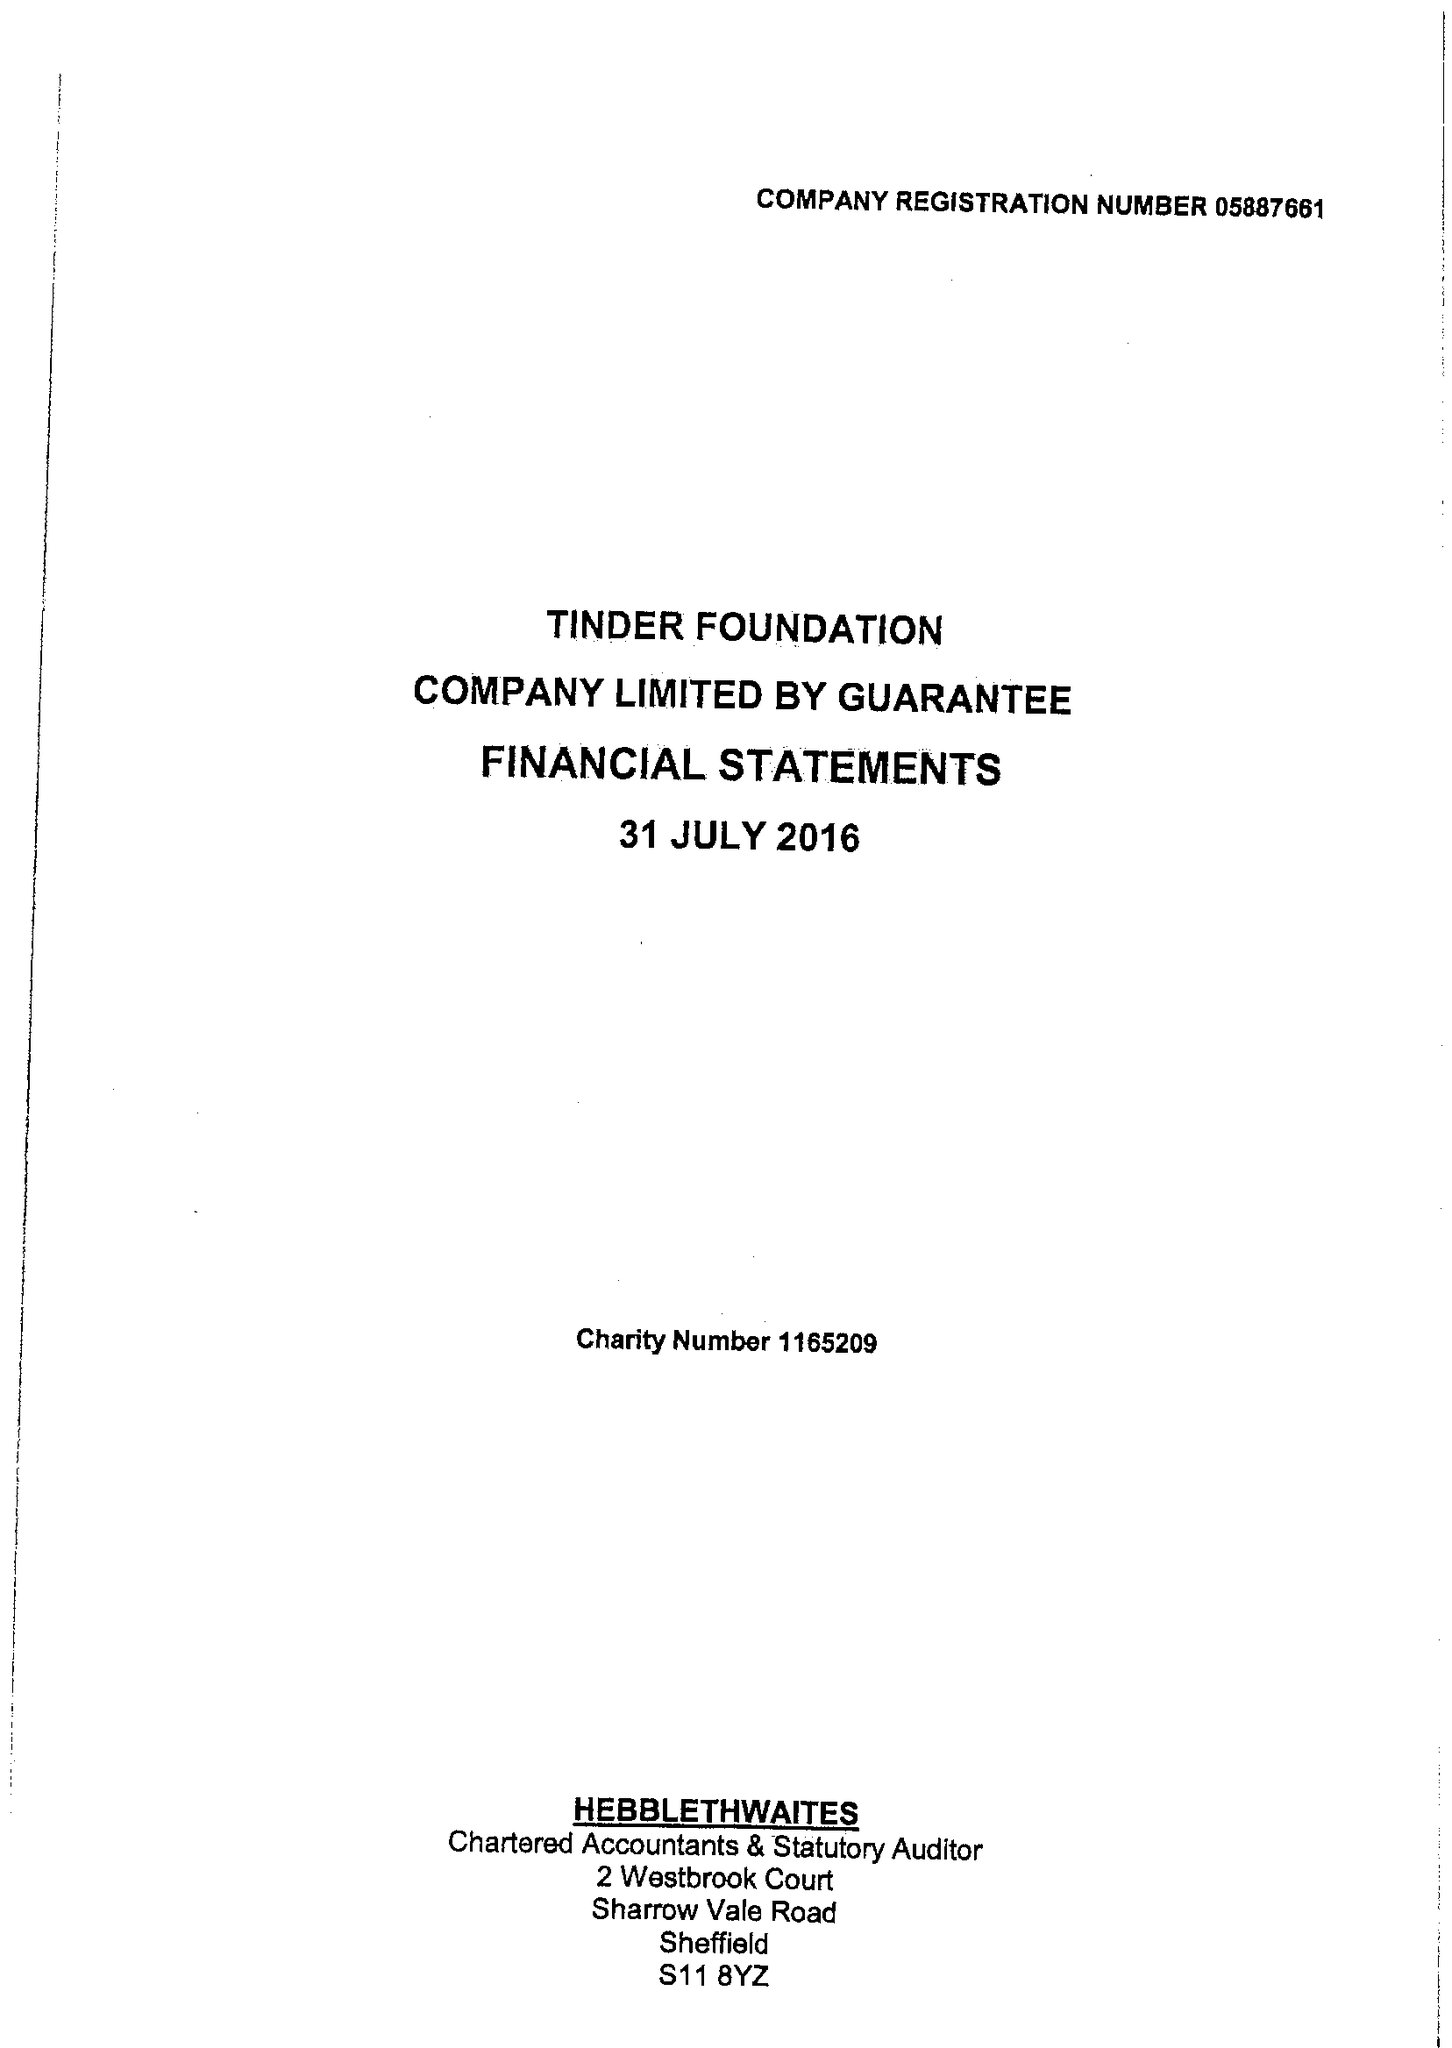What is the value for the address__postcode?
Answer the question using a single word or phrase. S1 2ET 